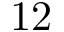<formula> <loc_0><loc_0><loc_500><loc_500>1 2</formula> 